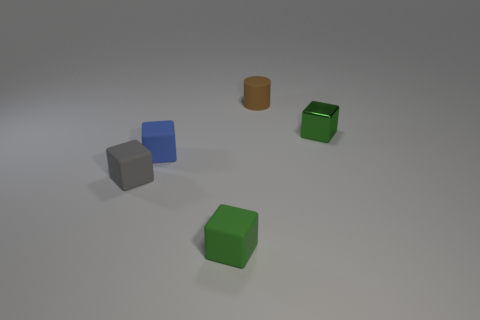What number of small green objects are there? There are exactly two small green objects. They appear to be cube-shaped and are positioned at varying distances within the scene. 